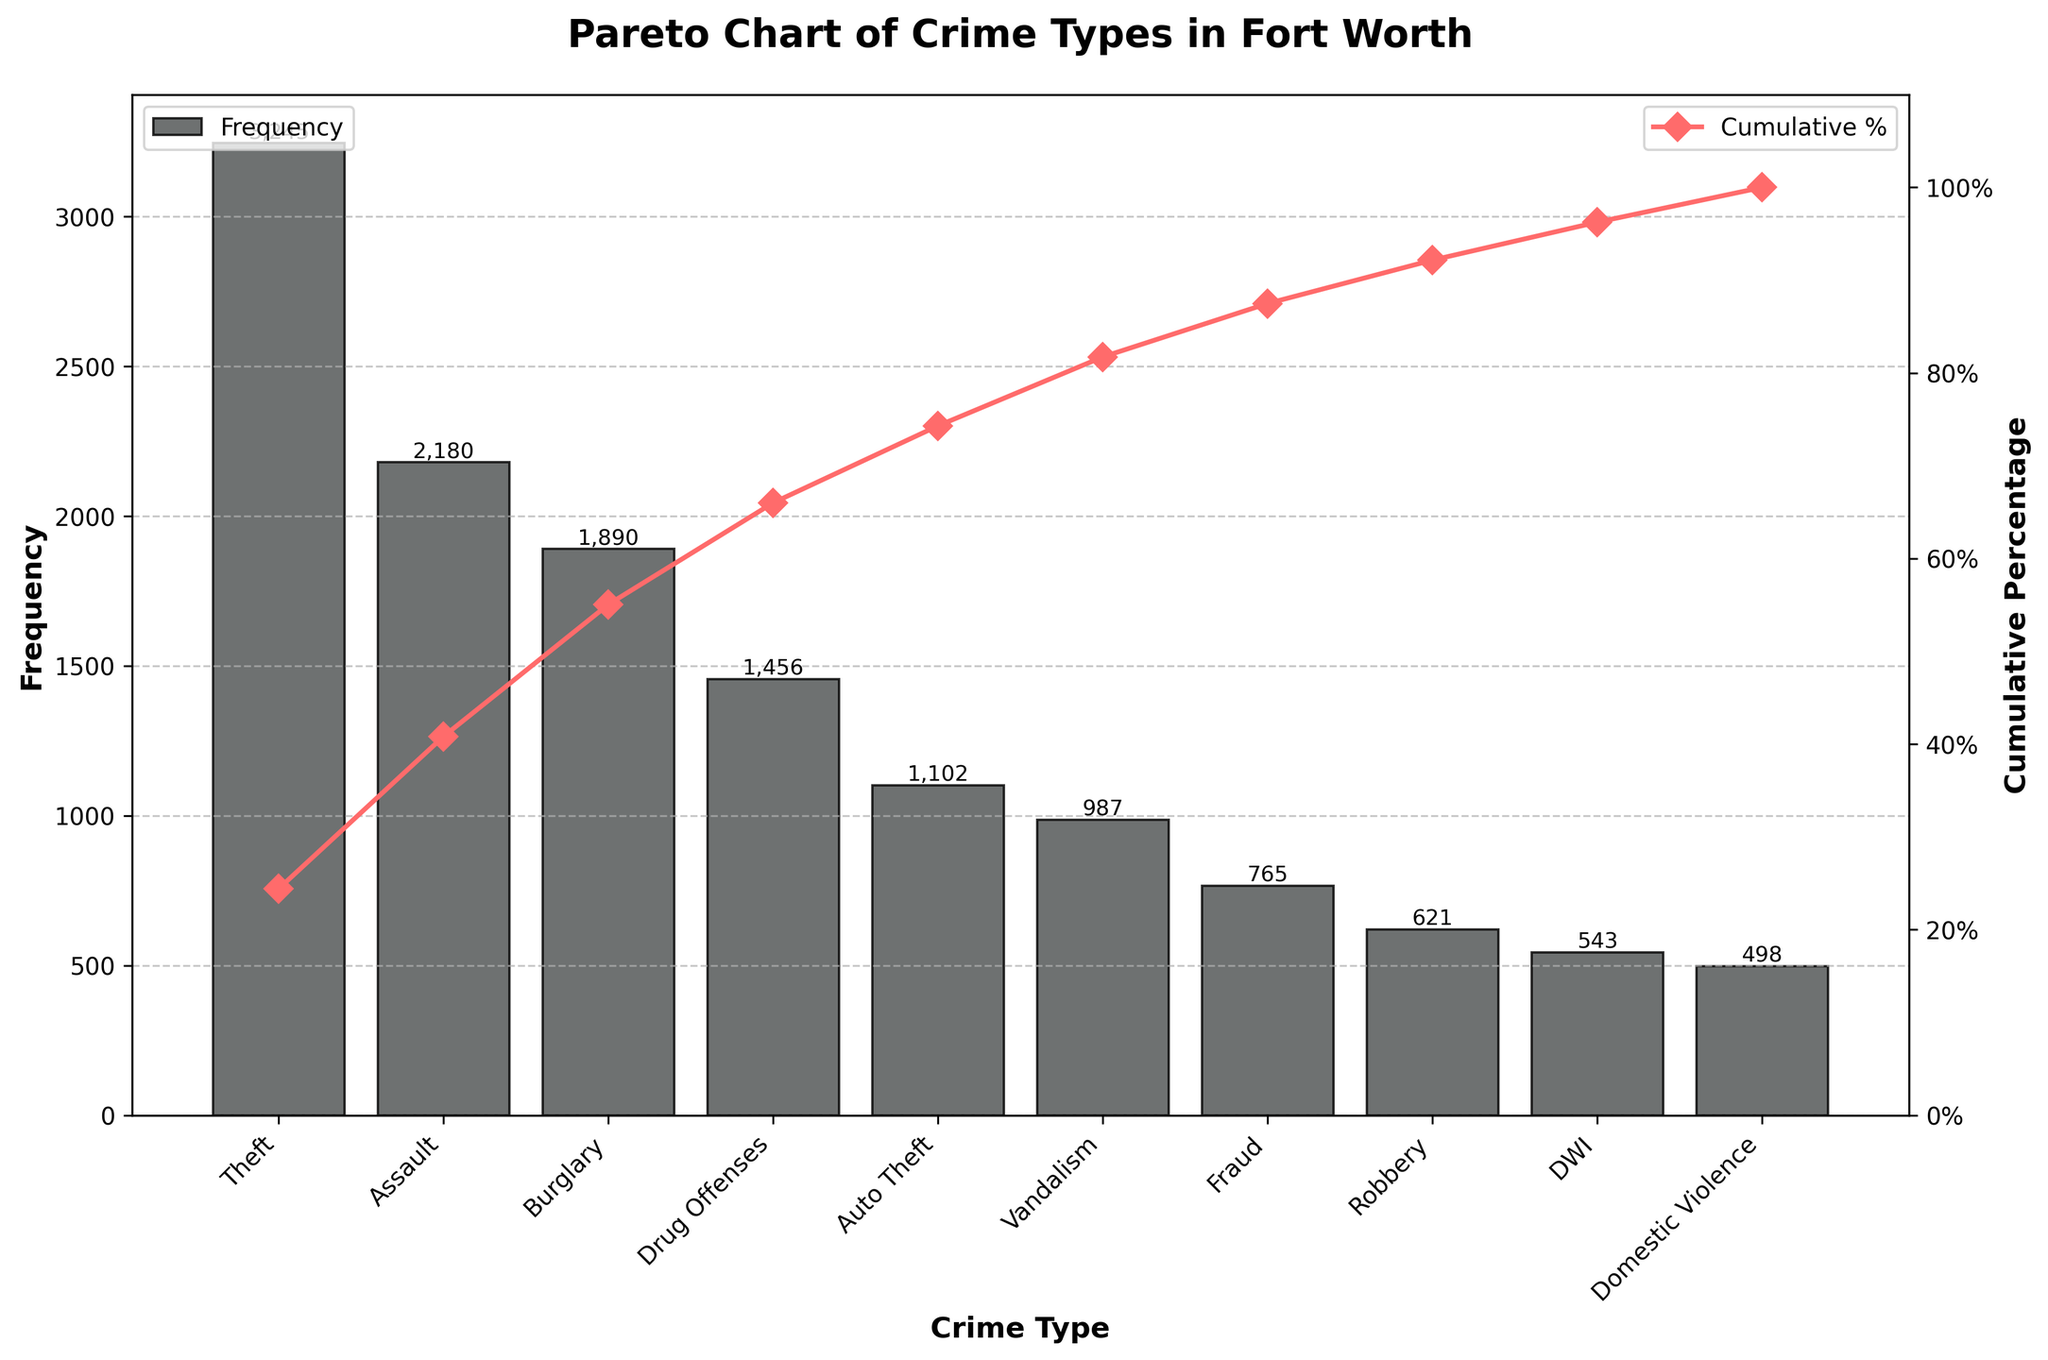Which crime type is reported the most in Fort Worth? To find the most reported crime type, look at the highest bar in the bar chart. The tallest bar represents Theft.
Answer: Theft What is the cumulative percentage of frequencies up to Burglary? The cumulative percentage up to Burglary is shown by the line graph. For Burglary, this percentage corresponds to the third point on the line graph.
Answer: Around 61% How many more Assaults than Auto Thefts are reported in Fort Worth? Subtract the frequency of Auto Thefts from the frequency of Assaults. 2180 (Assault) - 1102 (Auto Theft) = 1078
Answer: 1078 Which crime types contribute to the top 50% of all reported crimes? To find the crime types contributing to the top 50%, look at the cumulative percentage line. The line crosses the 50% mark between Assault and Burglary. So, Theft and Assault are the top contributors.
Answer: Theft, Assault What is the least reported crime type listed on the chart? Look at the shortest bar on the bar chart. The shortest bar represents Domestic Violence.
Answer: Domestic Violence How does the frequency of Fraud compare to that of Robbery? Compare the heights of the bars for Fraud and Robbery. The Fraud bar is higher than the Robbery bar.
Answer: Higher What percentage of the total crime reports is accounted for by the top three crime types? To find this, add the cumulative percentages up to the third crime type, which is Burglary (approximately 61%).
Answer: Around 61% What's the difference in cumulative percentage between Vandalism and Domestic Violence? Locate the cumulative percentages at Vandalism and Domestic Violence on the line graph. For Vandalism, it's around 85%, and for Domestic Violence, it's around 95%. Subtract these percentages.
Answer: Around 10% Considering the frequencies, which crime type falls at the median position when listed in descending order? To find the median, list all crime types in descending order of frequency. The 5th crime type in the list (Auto Theft) represents the median.
Answer: Auto Theft What is the combined frequency of DWI and Domestic Violence? Add the frequencies of DWI and Domestic Violence. 543 (DWI) + 498 (Domestic Violence) = 1041
Answer: 1041 